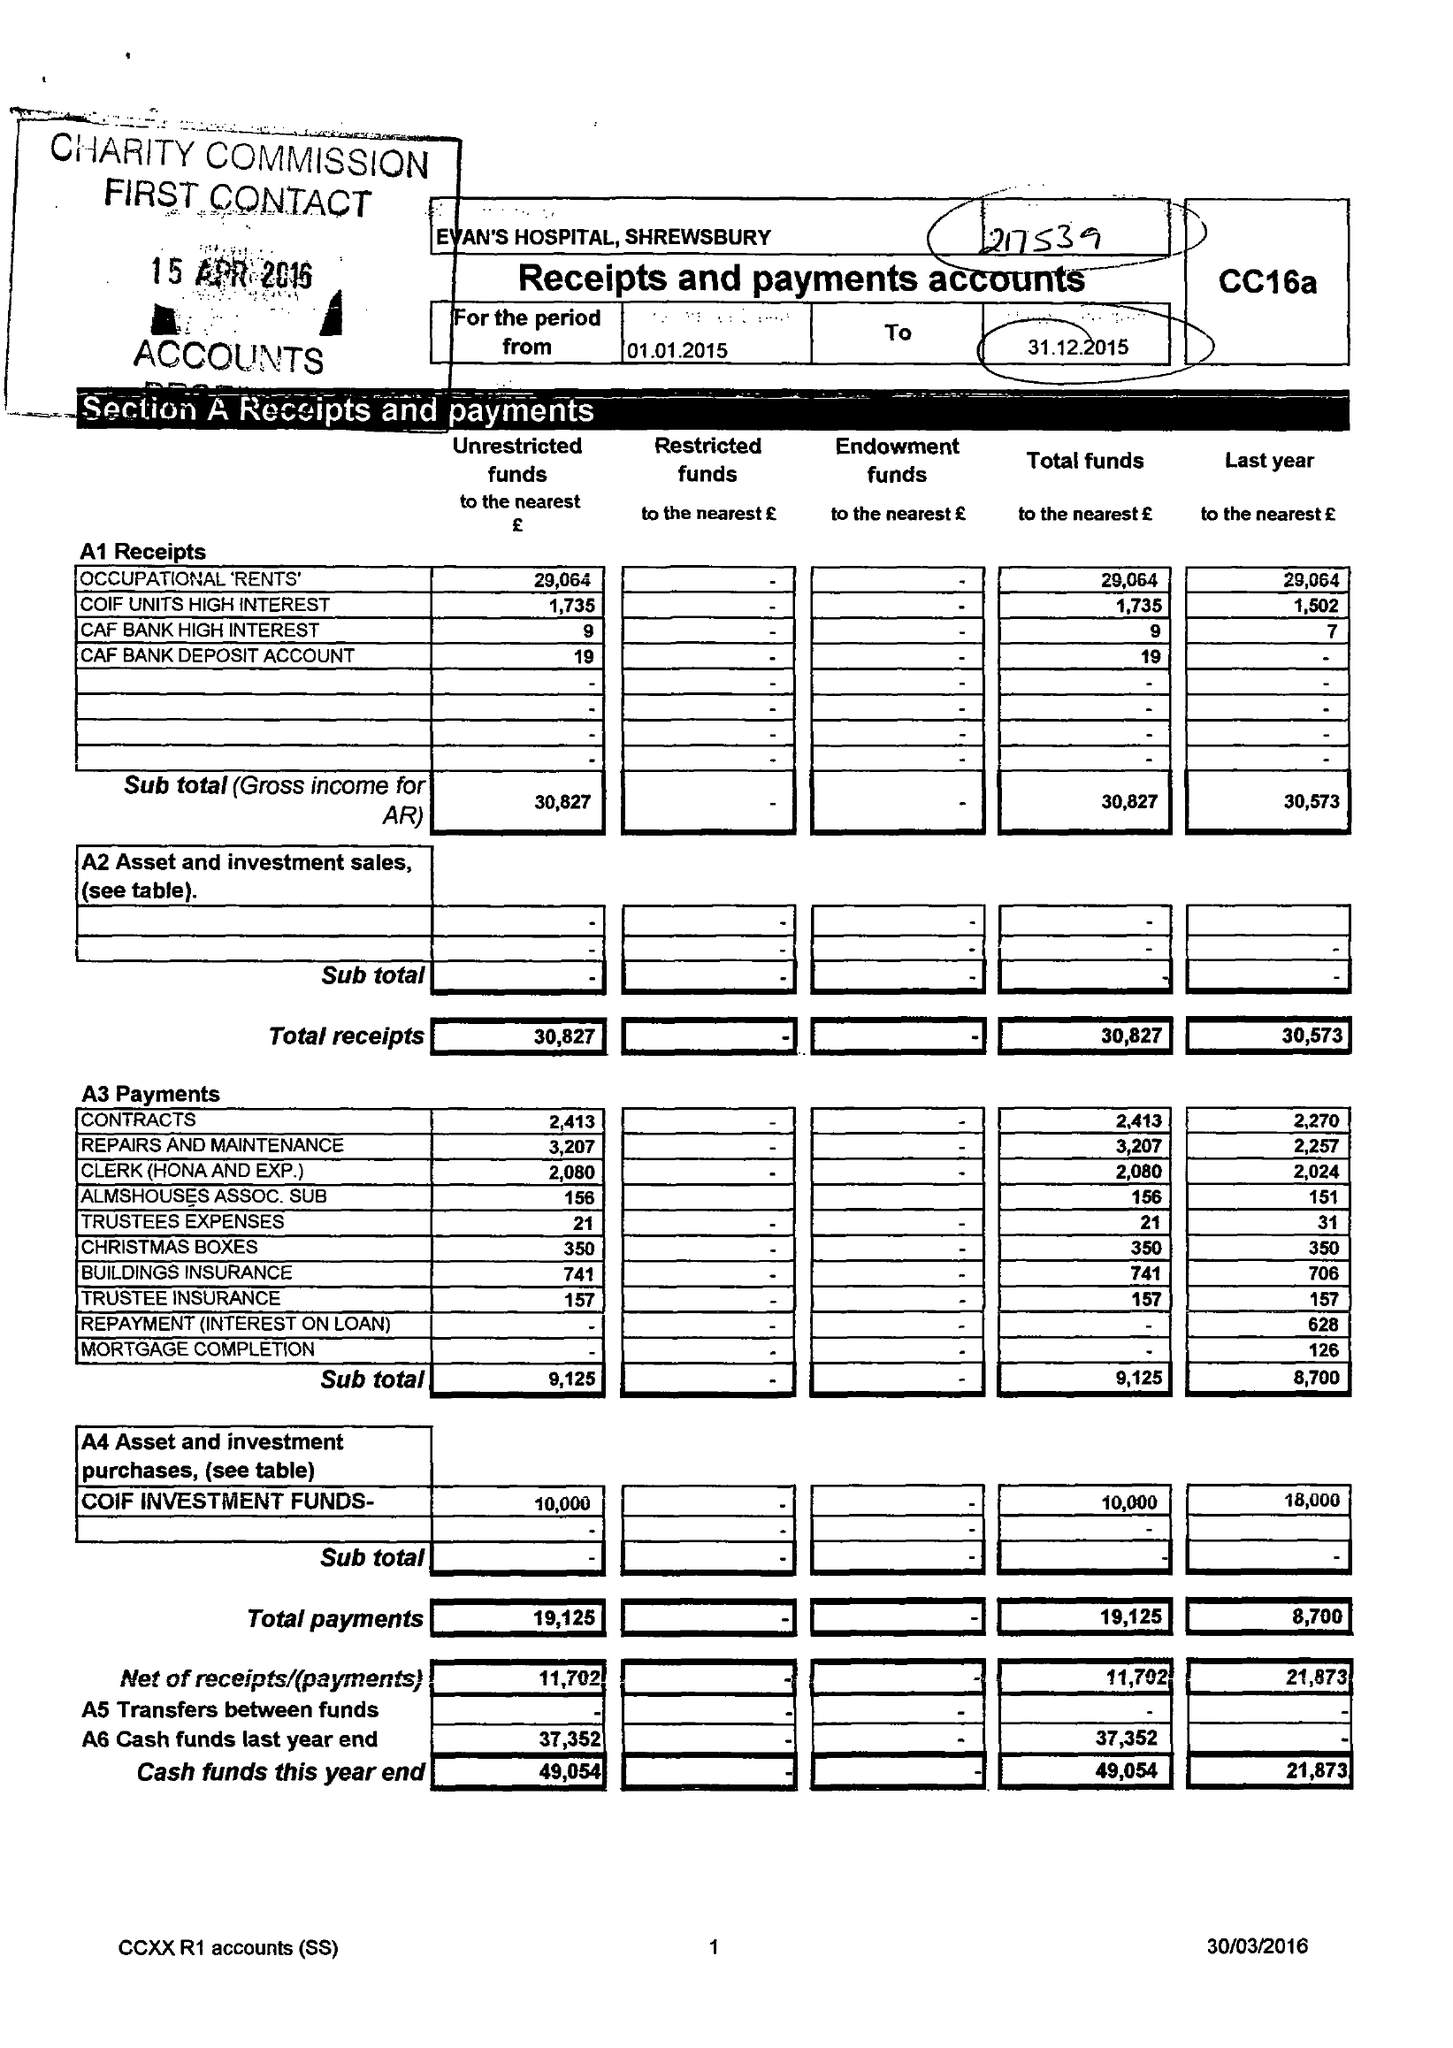What is the value for the charity_number?
Answer the question using a single word or phrase. 217539 